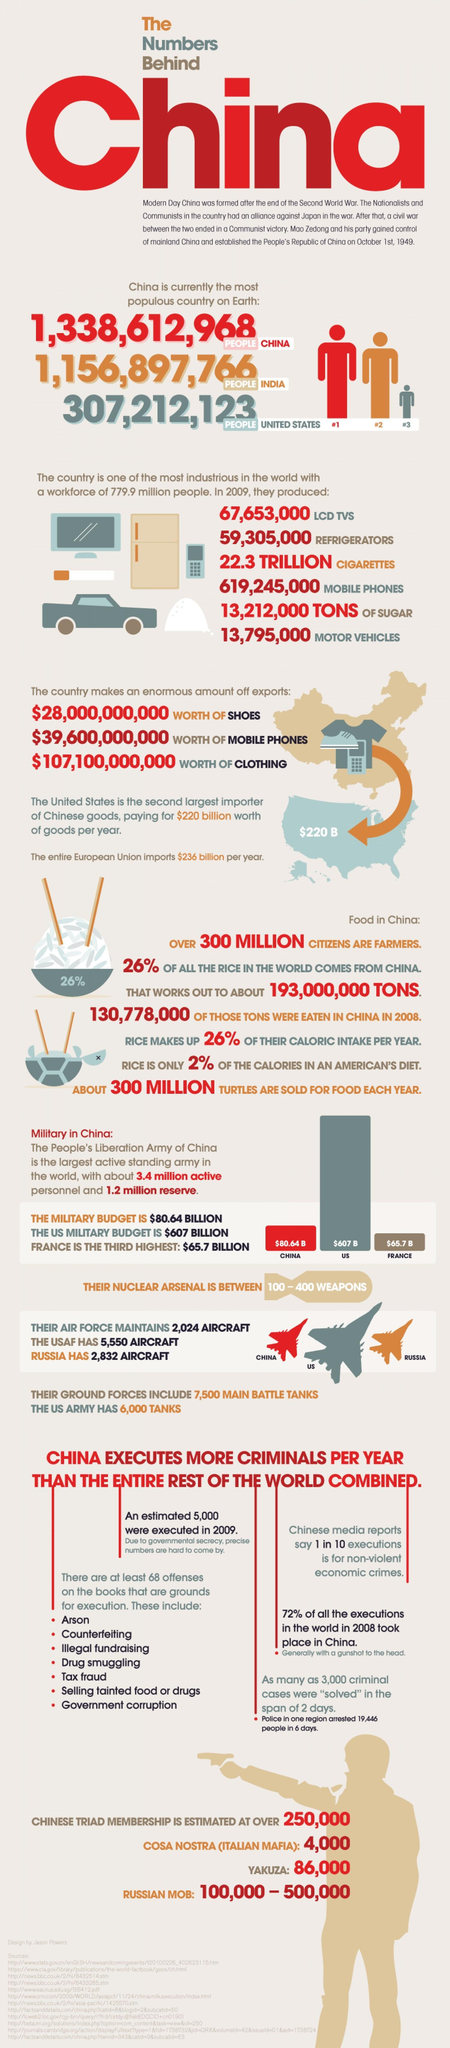How many things did China export?
Answer the question with a short phrase. 3 What percentage of Rice not coming from China? 74% How many things produced by china? 6 